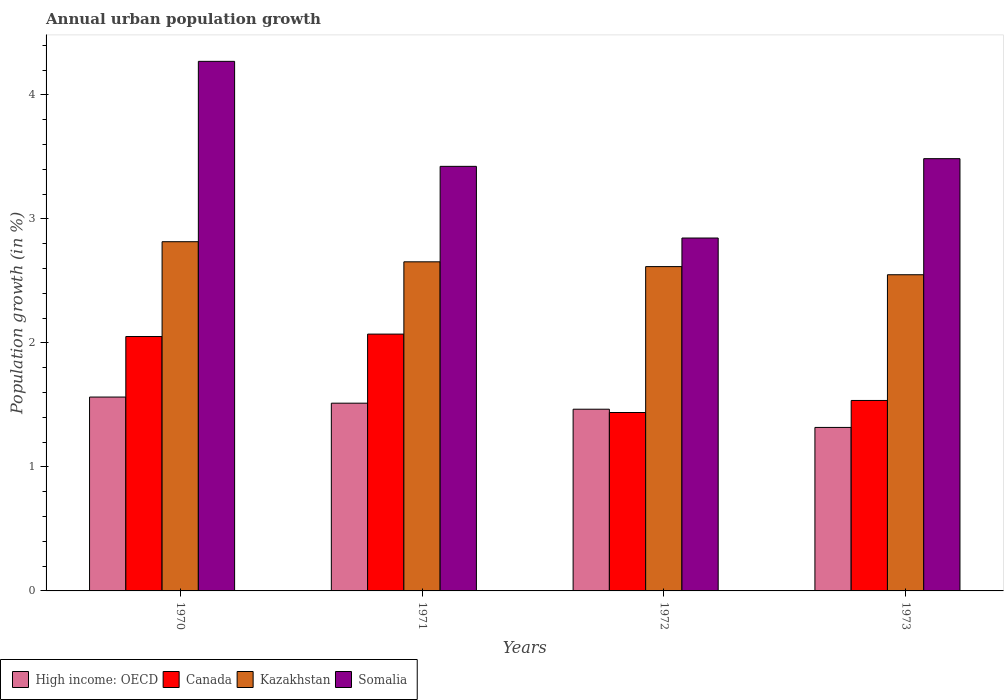Are the number of bars per tick equal to the number of legend labels?
Keep it short and to the point. Yes. Are the number of bars on each tick of the X-axis equal?
Keep it short and to the point. Yes. How many bars are there on the 1st tick from the right?
Make the answer very short. 4. What is the percentage of urban population growth in Kazakhstan in 1971?
Provide a short and direct response. 2.65. Across all years, what is the maximum percentage of urban population growth in Somalia?
Provide a succinct answer. 4.27. Across all years, what is the minimum percentage of urban population growth in High income: OECD?
Make the answer very short. 1.32. What is the total percentage of urban population growth in Canada in the graph?
Offer a terse response. 7.1. What is the difference between the percentage of urban population growth in Kazakhstan in 1972 and that in 1973?
Offer a very short reply. 0.07. What is the difference between the percentage of urban population growth in Somalia in 1973 and the percentage of urban population growth in High income: OECD in 1970?
Provide a succinct answer. 1.92. What is the average percentage of urban population growth in Canada per year?
Offer a very short reply. 1.77. In the year 1972, what is the difference between the percentage of urban population growth in Kazakhstan and percentage of urban population growth in Somalia?
Ensure brevity in your answer.  -0.23. What is the ratio of the percentage of urban population growth in Canada in 1972 to that in 1973?
Your answer should be very brief. 0.94. Is the percentage of urban population growth in Canada in 1971 less than that in 1973?
Offer a terse response. No. What is the difference between the highest and the second highest percentage of urban population growth in Canada?
Your response must be concise. 0.02. What is the difference between the highest and the lowest percentage of urban population growth in Kazakhstan?
Offer a very short reply. 0.27. What does the 1st bar from the left in 1972 represents?
Give a very brief answer. High income: OECD. What does the 1st bar from the right in 1973 represents?
Your response must be concise. Somalia. Are all the bars in the graph horizontal?
Your answer should be very brief. No. How many years are there in the graph?
Offer a terse response. 4. Does the graph contain grids?
Your answer should be very brief. No. How are the legend labels stacked?
Offer a terse response. Horizontal. What is the title of the graph?
Offer a very short reply. Annual urban population growth. What is the label or title of the X-axis?
Your answer should be very brief. Years. What is the label or title of the Y-axis?
Make the answer very short. Population growth (in %). What is the Population growth (in %) in High income: OECD in 1970?
Your response must be concise. 1.56. What is the Population growth (in %) of Canada in 1970?
Give a very brief answer. 2.05. What is the Population growth (in %) in Kazakhstan in 1970?
Offer a very short reply. 2.82. What is the Population growth (in %) in Somalia in 1970?
Make the answer very short. 4.27. What is the Population growth (in %) in High income: OECD in 1971?
Provide a succinct answer. 1.51. What is the Population growth (in %) in Canada in 1971?
Your answer should be compact. 2.07. What is the Population growth (in %) in Kazakhstan in 1971?
Provide a short and direct response. 2.65. What is the Population growth (in %) of Somalia in 1971?
Provide a succinct answer. 3.42. What is the Population growth (in %) in High income: OECD in 1972?
Your answer should be compact. 1.47. What is the Population growth (in %) in Canada in 1972?
Keep it short and to the point. 1.44. What is the Population growth (in %) of Kazakhstan in 1972?
Make the answer very short. 2.62. What is the Population growth (in %) of Somalia in 1972?
Provide a succinct answer. 2.85. What is the Population growth (in %) of High income: OECD in 1973?
Your answer should be very brief. 1.32. What is the Population growth (in %) of Canada in 1973?
Give a very brief answer. 1.54. What is the Population growth (in %) in Kazakhstan in 1973?
Keep it short and to the point. 2.55. What is the Population growth (in %) of Somalia in 1973?
Provide a succinct answer. 3.49. Across all years, what is the maximum Population growth (in %) in High income: OECD?
Make the answer very short. 1.56. Across all years, what is the maximum Population growth (in %) of Canada?
Your response must be concise. 2.07. Across all years, what is the maximum Population growth (in %) in Kazakhstan?
Ensure brevity in your answer.  2.82. Across all years, what is the maximum Population growth (in %) of Somalia?
Make the answer very short. 4.27. Across all years, what is the minimum Population growth (in %) of High income: OECD?
Offer a terse response. 1.32. Across all years, what is the minimum Population growth (in %) in Canada?
Your answer should be compact. 1.44. Across all years, what is the minimum Population growth (in %) in Kazakhstan?
Offer a terse response. 2.55. Across all years, what is the minimum Population growth (in %) in Somalia?
Your response must be concise. 2.85. What is the total Population growth (in %) in High income: OECD in the graph?
Give a very brief answer. 5.86. What is the total Population growth (in %) of Canada in the graph?
Provide a succinct answer. 7.1. What is the total Population growth (in %) in Kazakhstan in the graph?
Your response must be concise. 10.64. What is the total Population growth (in %) of Somalia in the graph?
Your answer should be very brief. 14.03. What is the difference between the Population growth (in %) of High income: OECD in 1970 and that in 1971?
Give a very brief answer. 0.05. What is the difference between the Population growth (in %) of Canada in 1970 and that in 1971?
Provide a succinct answer. -0.02. What is the difference between the Population growth (in %) in Kazakhstan in 1970 and that in 1971?
Your response must be concise. 0.16. What is the difference between the Population growth (in %) of Somalia in 1970 and that in 1971?
Your response must be concise. 0.85. What is the difference between the Population growth (in %) of High income: OECD in 1970 and that in 1972?
Provide a succinct answer. 0.1. What is the difference between the Population growth (in %) of Canada in 1970 and that in 1972?
Your answer should be compact. 0.61. What is the difference between the Population growth (in %) of Kazakhstan in 1970 and that in 1972?
Offer a terse response. 0.2. What is the difference between the Population growth (in %) of Somalia in 1970 and that in 1972?
Ensure brevity in your answer.  1.42. What is the difference between the Population growth (in %) of High income: OECD in 1970 and that in 1973?
Keep it short and to the point. 0.24. What is the difference between the Population growth (in %) in Canada in 1970 and that in 1973?
Offer a very short reply. 0.52. What is the difference between the Population growth (in %) of Kazakhstan in 1970 and that in 1973?
Your answer should be very brief. 0.27. What is the difference between the Population growth (in %) of Somalia in 1970 and that in 1973?
Ensure brevity in your answer.  0.78. What is the difference between the Population growth (in %) of High income: OECD in 1971 and that in 1972?
Offer a very short reply. 0.05. What is the difference between the Population growth (in %) in Canada in 1971 and that in 1972?
Keep it short and to the point. 0.63. What is the difference between the Population growth (in %) of Kazakhstan in 1971 and that in 1972?
Your answer should be compact. 0.04. What is the difference between the Population growth (in %) in Somalia in 1971 and that in 1972?
Give a very brief answer. 0.58. What is the difference between the Population growth (in %) in High income: OECD in 1971 and that in 1973?
Offer a terse response. 0.2. What is the difference between the Population growth (in %) of Canada in 1971 and that in 1973?
Offer a terse response. 0.54. What is the difference between the Population growth (in %) in Kazakhstan in 1971 and that in 1973?
Keep it short and to the point. 0.1. What is the difference between the Population growth (in %) of Somalia in 1971 and that in 1973?
Your answer should be very brief. -0.06. What is the difference between the Population growth (in %) of High income: OECD in 1972 and that in 1973?
Make the answer very short. 0.15. What is the difference between the Population growth (in %) of Canada in 1972 and that in 1973?
Keep it short and to the point. -0.1. What is the difference between the Population growth (in %) in Kazakhstan in 1972 and that in 1973?
Your answer should be very brief. 0.07. What is the difference between the Population growth (in %) of Somalia in 1972 and that in 1973?
Offer a very short reply. -0.64. What is the difference between the Population growth (in %) of High income: OECD in 1970 and the Population growth (in %) of Canada in 1971?
Your response must be concise. -0.51. What is the difference between the Population growth (in %) in High income: OECD in 1970 and the Population growth (in %) in Kazakhstan in 1971?
Offer a terse response. -1.09. What is the difference between the Population growth (in %) in High income: OECD in 1970 and the Population growth (in %) in Somalia in 1971?
Ensure brevity in your answer.  -1.86. What is the difference between the Population growth (in %) of Canada in 1970 and the Population growth (in %) of Kazakhstan in 1971?
Give a very brief answer. -0.6. What is the difference between the Population growth (in %) of Canada in 1970 and the Population growth (in %) of Somalia in 1971?
Provide a short and direct response. -1.37. What is the difference between the Population growth (in %) of Kazakhstan in 1970 and the Population growth (in %) of Somalia in 1971?
Make the answer very short. -0.61. What is the difference between the Population growth (in %) in High income: OECD in 1970 and the Population growth (in %) in Canada in 1972?
Keep it short and to the point. 0.12. What is the difference between the Population growth (in %) of High income: OECD in 1970 and the Population growth (in %) of Kazakhstan in 1972?
Make the answer very short. -1.05. What is the difference between the Population growth (in %) in High income: OECD in 1970 and the Population growth (in %) in Somalia in 1972?
Offer a terse response. -1.28. What is the difference between the Population growth (in %) of Canada in 1970 and the Population growth (in %) of Kazakhstan in 1972?
Your answer should be compact. -0.56. What is the difference between the Population growth (in %) of Canada in 1970 and the Population growth (in %) of Somalia in 1972?
Provide a succinct answer. -0.79. What is the difference between the Population growth (in %) in Kazakhstan in 1970 and the Population growth (in %) in Somalia in 1972?
Offer a terse response. -0.03. What is the difference between the Population growth (in %) of High income: OECD in 1970 and the Population growth (in %) of Canada in 1973?
Provide a short and direct response. 0.03. What is the difference between the Population growth (in %) of High income: OECD in 1970 and the Population growth (in %) of Kazakhstan in 1973?
Give a very brief answer. -0.99. What is the difference between the Population growth (in %) in High income: OECD in 1970 and the Population growth (in %) in Somalia in 1973?
Make the answer very short. -1.92. What is the difference between the Population growth (in %) in Canada in 1970 and the Population growth (in %) in Kazakhstan in 1973?
Offer a very short reply. -0.5. What is the difference between the Population growth (in %) of Canada in 1970 and the Population growth (in %) of Somalia in 1973?
Ensure brevity in your answer.  -1.43. What is the difference between the Population growth (in %) of Kazakhstan in 1970 and the Population growth (in %) of Somalia in 1973?
Give a very brief answer. -0.67. What is the difference between the Population growth (in %) in High income: OECD in 1971 and the Population growth (in %) in Canada in 1972?
Your response must be concise. 0.08. What is the difference between the Population growth (in %) in High income: OECD in 1971 and the Population growth (in %) in Kazakhstan in 1972?
Your answer should be compact. -1.1. What is the difference between the Population growth (in %) in High income: OECD in 1971 and the Population growth (in %) in Somalia in 1972?
Provide a succinct answer. -1.33. What is the difference between the Population growth (in %) in Canada in 1971 and the Population growth (in %) in Kazakhstan in 1972?
Your answer should be very brief. -0.54. What is the difference between the Population growth (in %) of Canada in 1971 and the Population growth (in %) of Somalia in 1972?
Provide a short and direct response. -0.77. What is the difference between the Population growth (in %) in Kazakhstan in 1971 and the Population growth (in %) in Somalia in 1972?
Provide a succinct answer. -0.19. What is the difference between the Population growth (in %) of High income: OECD in 1971 and the Population growth (in %) of Canada in 1973?
Make the answer very short. -0.02. What is the difference between the Population growth (in %) in High income: OECD in 1971 and the Population growth (in %) in Kazakhstan in 1973?
Offer a terse response. -1.04. What is the difference between the Population growth (in %) of High income: OECD in 1971 and the Population growth (in %) of Somalia in 1973?
Offer a terse response. -1.97. What is the difference between the Population growth (in %) in Canada in 1971 and the Population growth (in %) in Kazakhstan in 1973?
Provide a succinct answer. -0.48. What is the difference between the Population growth (in %) in Canada in 1971 and the Population growth (in %) in Somalia in 1973?
Provide a short and direct response. -1.41. What is the difference between the Population growth (in %) of Kazakhstan in 1971 and the Population growth (in %) of Somalia in 1973?
Ensure brevity in your answer.  -0.83. What is the difference between the Population growth (in %) of High income: OECD in 1972 and the Population growth (in %) of Canada in 1973?
Make the answer very short. -0.07. What is the difference between the Population growth (in %) of High income: OECD in 1972 and the Population growth (in %) of Kazakhstan in 1973?
Ensure brevity in your answer.  -1.08. What is the difference between the Population growth (in %) in High income: OECD in 1972 and the Population growth (in %) in Somalia in 1973?
Keep it short and to the point. -2.02. What is the difference between the Population growth (in %) in Canada in 1972 and the Population growth (in %) in Kazakhstan in 1973?
Make the answer very short. -1.11. What is the difference between the Population growth (in %) of Canada in 1972 and the Population growth (in %) of Somalia in 1973?
Offer a very short reply. -2.05. What is the difference between the Population growth (in %) in Kazakhstan in 1972 and the Population growth (in %) in Somalia in 1973?
Keep it short and to the point. -0.87. What is the average Population growth (in %) of High income: OECD per year?
Offer a very short reply. 1.47. What is the average Population growth (in %) of Canada per year?
Your response must be concise. 1.77. What is the average Population growth (in %) of Kazakhstan per year?
Your response must be concise. 2.66. What is the average Population growth (in %) in Somalia per year?
Offer a very short reply. 3.51. In the year 1970, what is the difference between the Population growth (in %) of High income: OECD and Population growth (in %) of Canada?
Keep it short and to the point. -0.49. In the year 1970, what is the difference between the Population growth (in %) in High income: OECD and Population growth (in %) in Kazakhstan?
Offer a terse response. -1.25. In the year 1970, what is the difference between the Population growth (in %) of High income: OECD and Population growth (in %) of Somalia?
Your response must be concise. -2.71. In the year 1970, what is the difference between the Population growth (in %) in Canada and Population growth (in %) in Kazakhstan?
Your answer should be very brief. -0.76. In the year 1970, what is the difference between the Population growth (in %) in Canada and Population growth (in %) in Somalia?
Offer a very short reply. -2.22. In the year 1970, what is the difference between the Population growth (in %) in Kazakhstan and Population growth (in %) in Somalia?
Offer a terse response. -1.45. In the year 1971, what is the difference between the Population growth (in %) in High income: OECD and Population growth (in %) in Canada?
Your answer should be very brief. -0.56. In the year 1971, what is the difference between the Population growth (in %) in High income: OECD and Population growth (in %) in Kazakhstan?
Provide a short and direct response. -1.14. In the year 1971, what is the difference between the Population growth (in %) in High income: OECD and Population growth (in %) in Somalia?
Keep it short and to the point. -1.91. In the year 1971, what is the difference between the Population growth (in %) of Canada and Population growth (in %) of Kazakhstan?
Provide a succinct answer. -0.58. In the year 1971, what is the difference between the Population growth (in %) in Canada and Population growth (in %) in Somalia?
Offer a terse response. -1.35. In the year 1971, what is the difference between the Population growth (in %) of Kazakhstan and Population growth (in %) of Somalia?
Your answer should be very brief. -0.77. In the year 1972, what is the difference between the Population growth (in %) of High income: OECD and Population growth (in %) of Canada?
Make the answer very short. 0.03. In the year 1972, what is the difference between the Population growth (in %) of High income: OECD and Population growth (in %) of Kazakhstan?
Your response must be concise. -1.15. In the year 1972, what is the difference between the Population growth (in %) of High income: OECD and Population growth (in %) of Somalia?
Give a very brief answer. -1.38. In the year 1972, what is the difference between the Population growth (in %) of Canada and Population growth (in %) of Kazakhstan?
Keep it short and to the point. -1.18. In the year 1972, what is the difference between the Population growth (in %) in Canada and Population growth (in %) in Somalia?
Give a very brief answer. -1.41. In the year 1972, what is the difference between the Population growth (in %) of Kazakhstan and Population growth (in %) of Somalia?
Keep it short and to the point. -0.23. In the year 1973, what is the difference between the Population growth (in %) of High income: OECD and Population growth (in %) of Canada?
Offer a terse response. -0.22. In the year 1973, what is the difference between the Population growth (in %) of High income: OECD and Population growth (in %) of Kazakhstan?
Ensure brevity in your answer.  -1.23. In the year 1973, what is the difference between the Population growth (in %) of High income: OECD and Population growth (in %) of Somalia?
Provide a succinct answer. -2.17. In the year 1973, what is the difference between the Population growth (in %) of Canada and Population growth (in %) of Kazakhstan?
Ensure brevity in your answer.  -1.01. In the year 1973, what is the difference between the Population growth (in %) of Canada and Population growth (in %) of Somalia?
Give a very brief answer. -1.95. In the year 1973, what is the difference between the Population growth (in %) in Kazakhstan and Population growth (in %) in Somalia?
Give a very brief answer. -0.94. What is the ratio of the Population growth (in %) in High income: OECD in 1970 to that in 1971?
Offer a terse response. 1.03. What is the ratio of the Population growth (in %) in Kazakhstan in 1970 to that in 1971?
Ensure brevity in your answer.  1.06. What is the ratio of the Population growth (in %) of Somalia in 1970 to that in 1971?
Offer a very short reply. 1.25. What is the ratio of the Population growth (in %) in High income: OECD in 1970 to that in 1972?
Provide a succinct answer. 1.07. What is the ratio of the Population growth (in %) of Canada in 1970 to that in 1972?
Provide a short and direct response. 1.43. What is the ratio of the Population growth (in %) of Kazakhstan in 1970 to that in 1972?
Your response must be concise. 1.08. What is the ratio of the Population growth (in %) of Somalia in 1970 to that in 1972?
Provide a succinct answer. 1.5. What is the ratio of the Population growth (in %) in High income: OECD in 1970 to that in 1973?
Provide a succinct answer. 1.19. What is the ratio of the Population growth (in %) in Canada in 1970 to that in 1973?
Your answer should be compact. 1.34. What is the ratio of the Population growth (in %) in Kazakhstan in 1970 to that in 1973?
Offer a very short reply. 1.1. What is the ratio of the Population growth (in %) of Somalia in 1970 to that in 1973?
Your answer should be very brief. 1.23. What is the ratio of the Population growth (in %) of High income: OECD in 1971 to that in 1972?
Keep it short and to the point. 1.03. What is the ratio of the Population growth (in %) of Canada in 1971 to that in 1972?
Your answer should be very brief. 1.44. What is the ratio of the Population growth (in %) of Kazakhstan in 1971 to that in 1972?
Your answer should be very brief. 1.01. What is the ratio of the Population growth (in %) of Somalia in 1971 to that in 1972?
Make the answer very short. 1.2. What is the ratio of the Population growth (in %) in High income: OECD in 1971 to that in 1973?
Provide a succinct answer. 1.15. What is the ratio of the Population growth (in %) of Canada in 1971 to that in 1973?
Your response must be concise. 1.35. What is the ratio of the Population growth (in %) in Kazakhstan in 1971 to that in 1973?
Your response must be concise. 1.04. What is the ratio of the Population growth (in %) of Somalia in 1971 to that in 1973?
Ensure brevity in your answer.  0.98. What is the ratio of the Population growth (in %) of High income: OECD in 1972 to that in 1973?
Provide a succinct answer. 1.11. What is the ratio of the Population growth (in %) of Canada in 1972 to that in 1973?
Provide a short and direct response. 0.94. What is the ratio of the Population growth (in %) of Kazakhstan in 1972 to that in 1973?
Provide a short and direct response. 1.03. What is the ratio of the Population growth (in %) in Somalia in 1972 to that in 1973?
Your answer should be compact. 0.82. What is the difference between the highest and the second highest Population growth (in %) of High income: OECD?
Your response must be concise. 0.05. What is the difference between the highest and the second highest Population growth (in %) in Canada?
Ensure brevity in your answer.  0.02. What is the difference between the highest and the second highest Population growth (in %) in Kazakhstan?
Ensure brevity in your answer.  0.16. What is the difference between the highest and the second highest Population growth (in %) in Somalia?
Your answer should be compact. 0.78. What is the difference between the highest and the lowest Population growth (in %) in High income: OECD?
Make the answer very short. 0.24. What is the difference between the highest and the lowest Population growth (in %) in Canada?
Make the answer very short. 0.63. What is the difference between the highest and the lowest Population growth (in %) in Kazakhstan?
Offer a terse response. 0.27. What is the difference between the highest and the lowest Population growth (in %) of Somalia?
Your response must be concise. 1.42. 